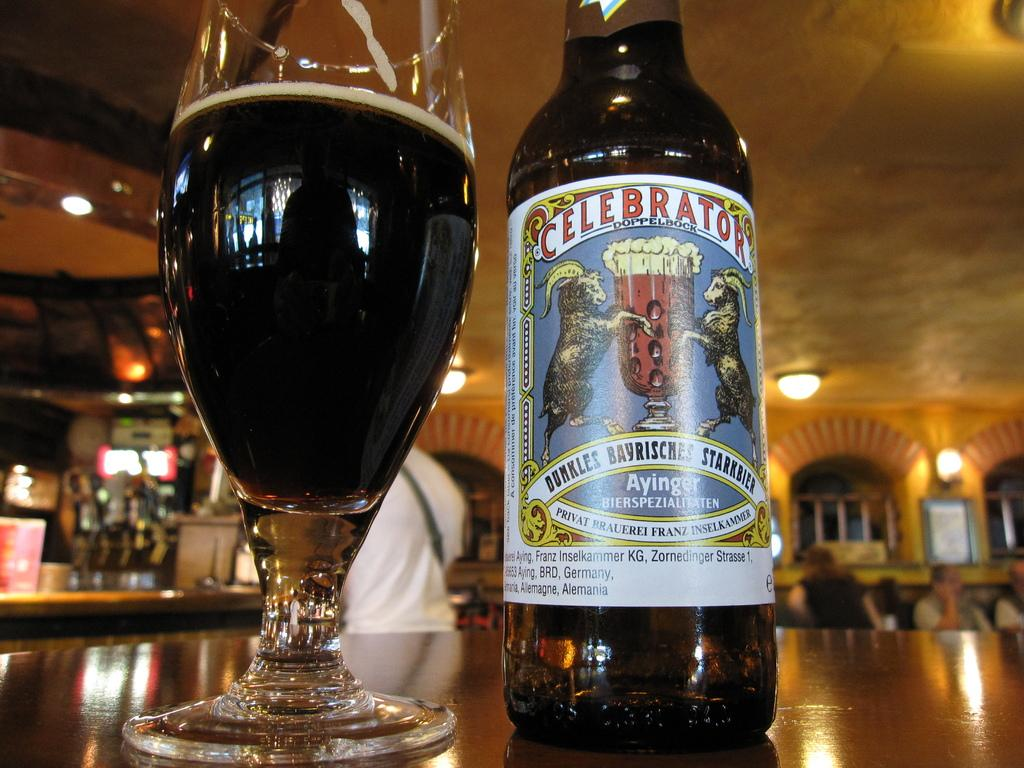Provide a one-sentence caption for the provided image. A glass of Celebrator beer next to its bottle. 